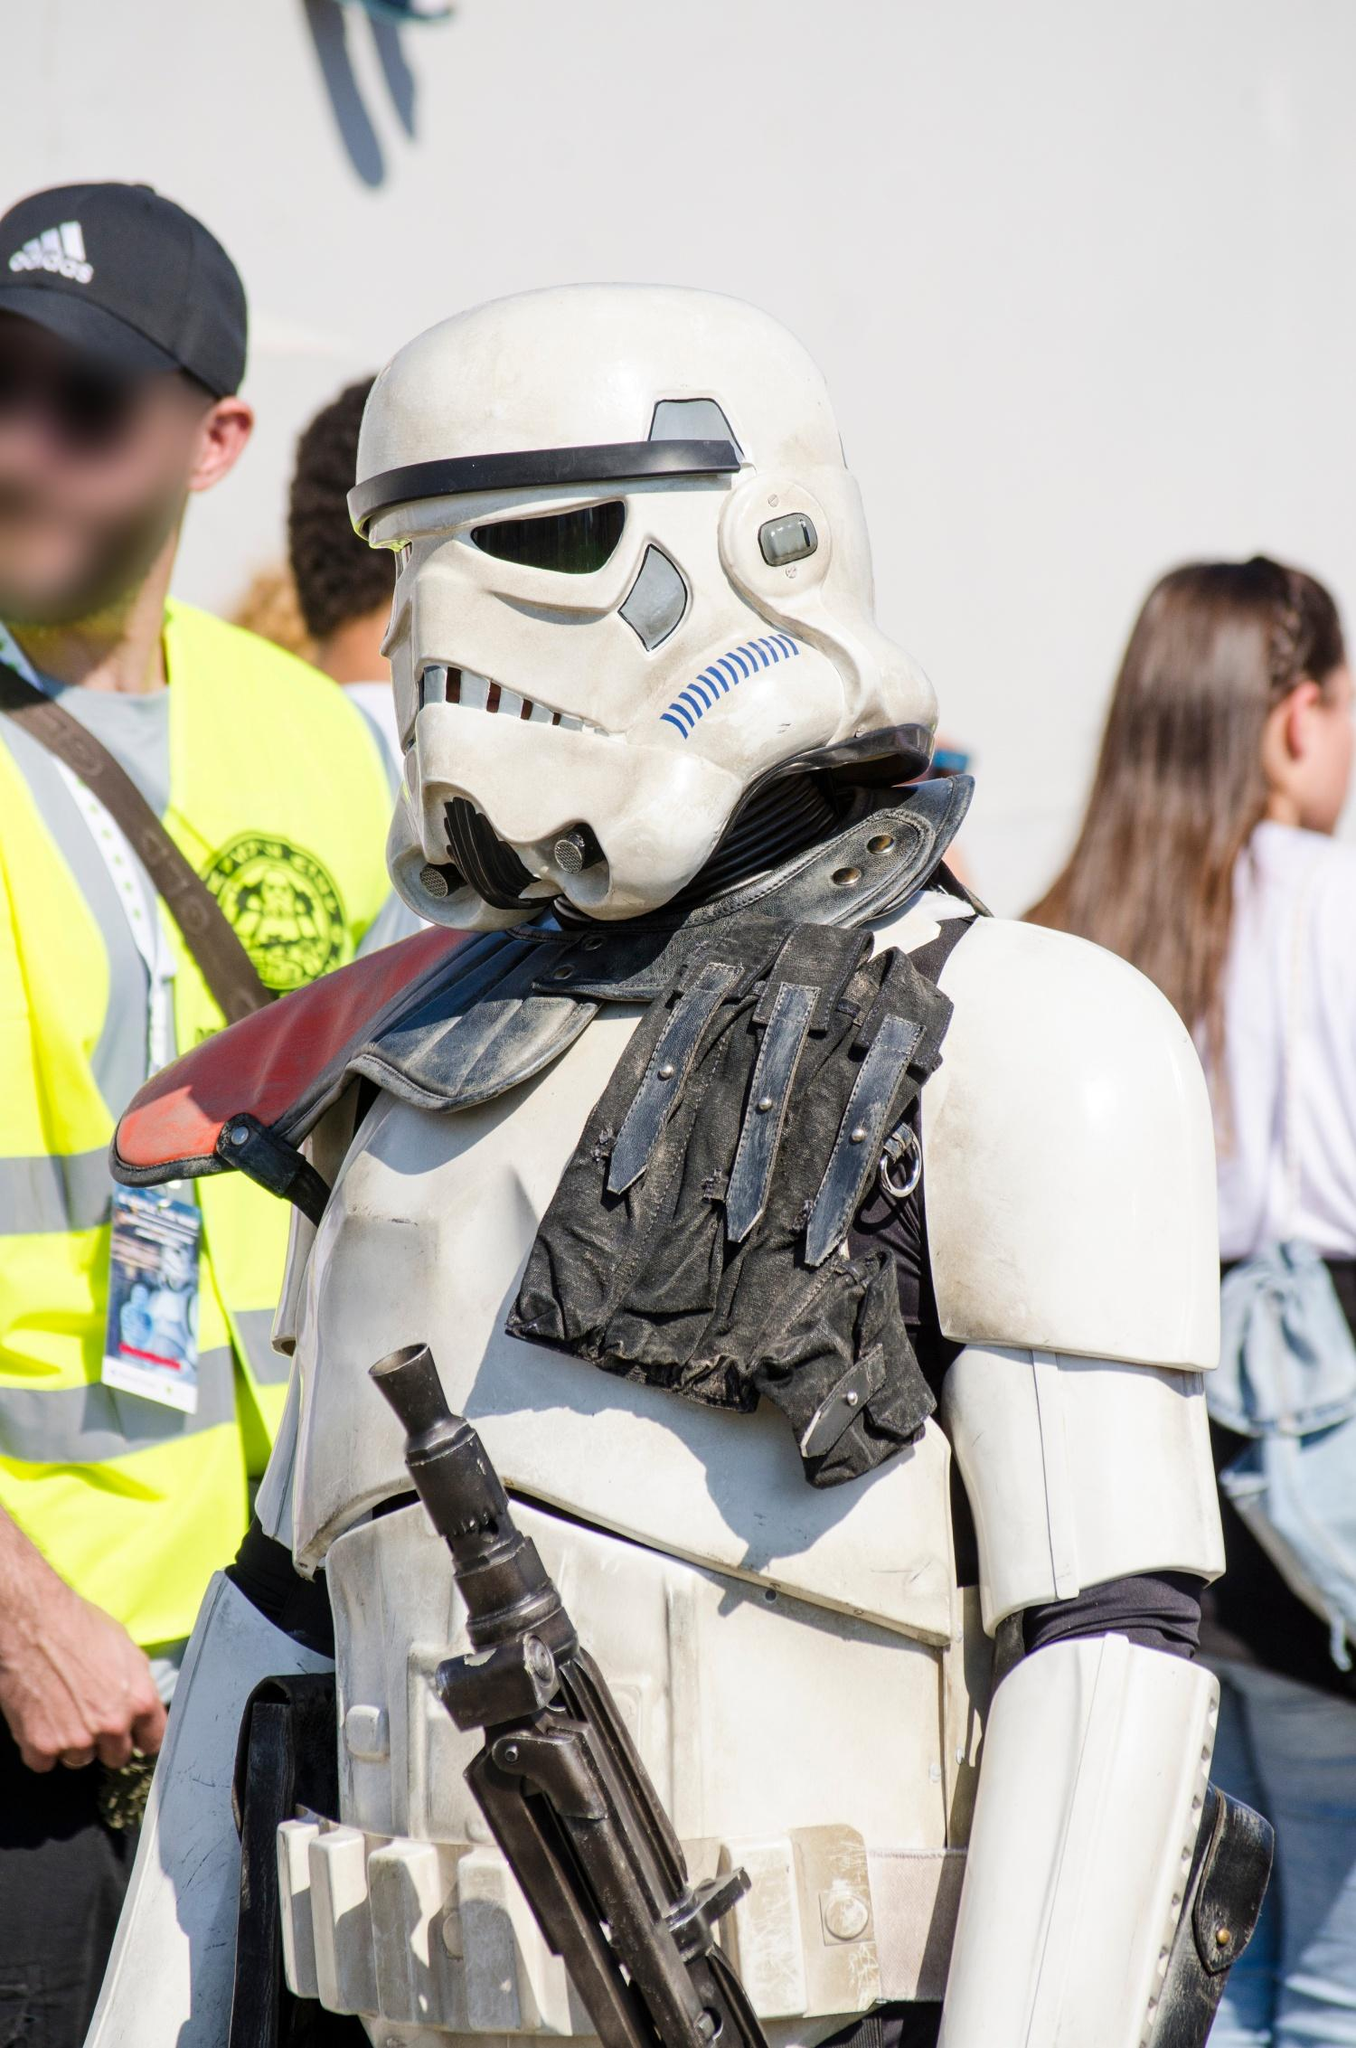What does the presence of a security guard in the background suggest about the event? The presence of a security guard in the background suggests that the event is likely a large, organized public gathering, such as a fan convention or a themed festival. Security personnel are typically hired to ensure the safety and order of attendees, manage crowd control, and provide assistance in case of emergencies. This indicates that the event is significant, drawing a considerable number of participants where security measures are necessary.  What kind of interactions do you think the person in the Stormtrooper costume had with other attendees at the event? The person in the Stormtrooper costume probably had numerous enthusiastic interactions with other attendees at the event. Fans of all ages would approach them for photographs, compliments on their costume, and to share their love for Star Wars. Children might have been especially excited to see a Stormtrooper and asked for high-fives or posed in fighting stances for fun photos. Fellow cosplayers would likely engage in conversations about costume making, sharing tips and praising the craftsmanship. There could also have been light-hearted moments where the Stormtrooper play-acted scenes from the movies, adding to the overall enjoyment and engagement at the event. 